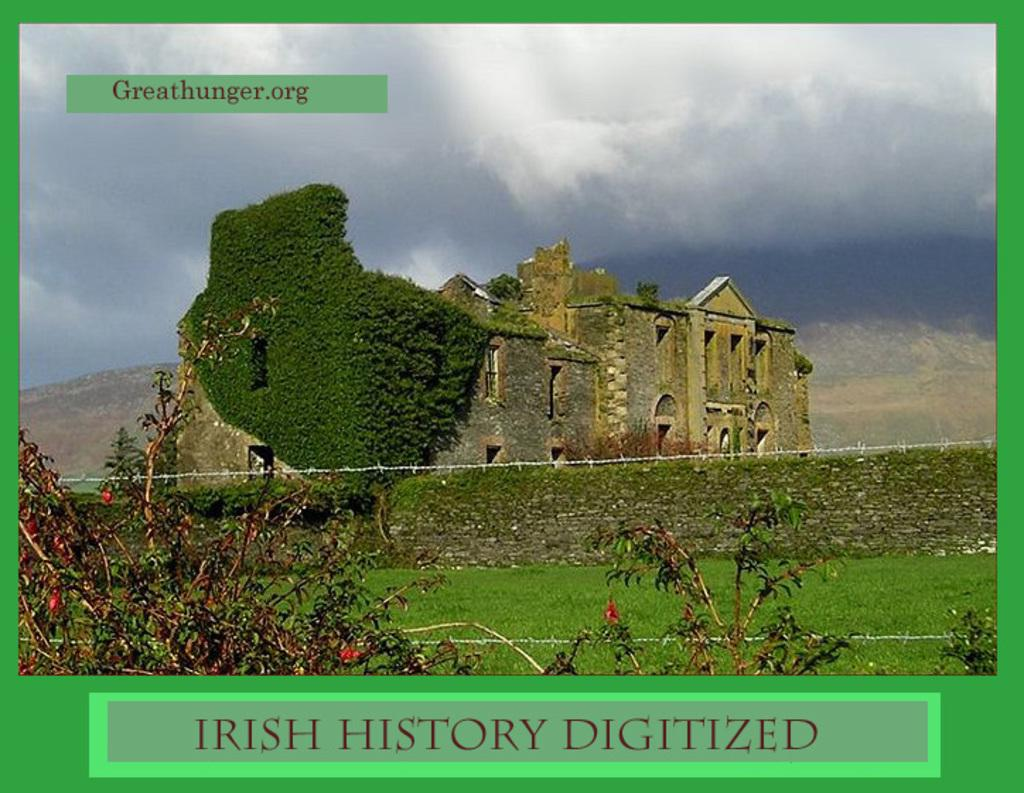What type of living organisms can be seen in the image? Plants and trees are visible in the image. What type of structure can be seen in the image? There is a building in the image. What type of architectural feature is present in the image? There is a fence in the image. What type of vegetation is visible in the image? Grass is visible in the image. What natural features can be seen in the image? Mountains are visible in the image. What is the condition of the sky in the image? The sky contains clouds in the image. Can you tell me how many baby bears are playing with a pot in the image? There are no baby bears or pots present in the image. 